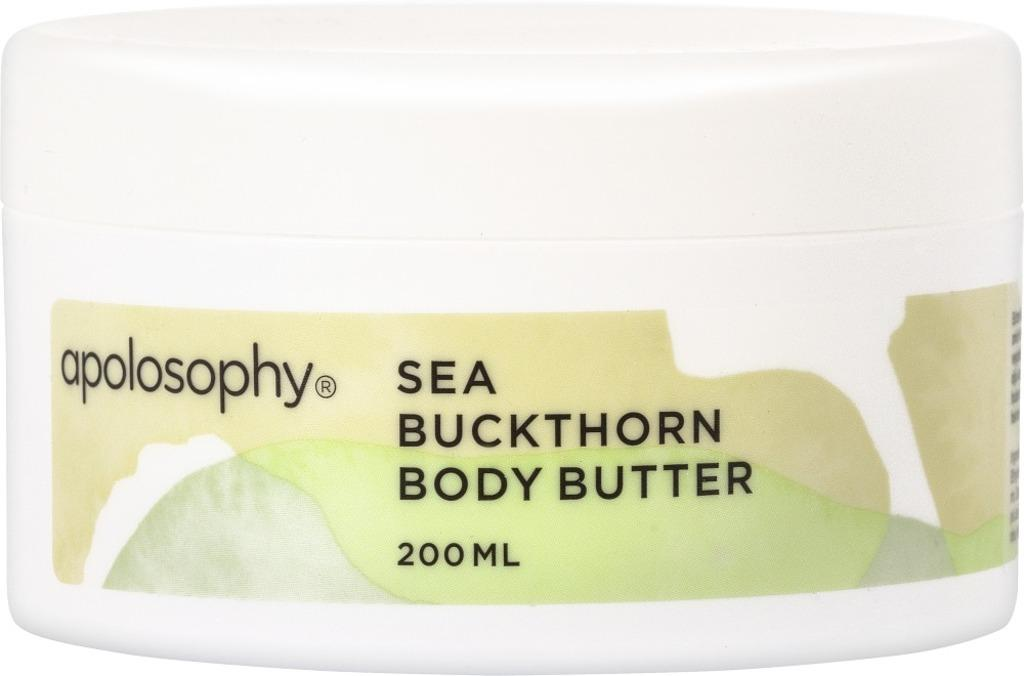<image>
Describe the image concisely. Sea Buckthorn Body Butter from Apolosophy which is 200 ml. 